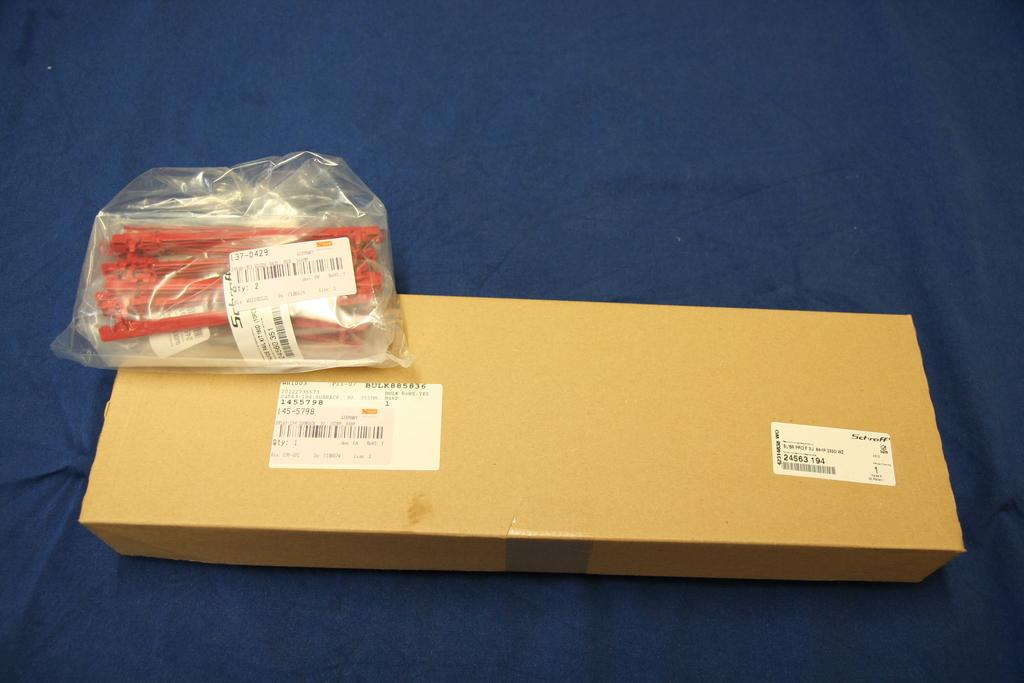What type of furniture is present in the image? There is a table in the image. What is covering the table? There is a blue colored cloth on the table. What object is placed on the table? There is a box on the table. What is covering the box? There is a cover on the table. What can be seen inside the cover? There are instruments visible inside the cover. What type of drum is visible on the table? There is no drum present in the image. What effect does the blue colored cloth have on the instruments inside the cover? The blue colored cloth does not have any effect on the instruments inside the cover; it is simply a covering for the table. 